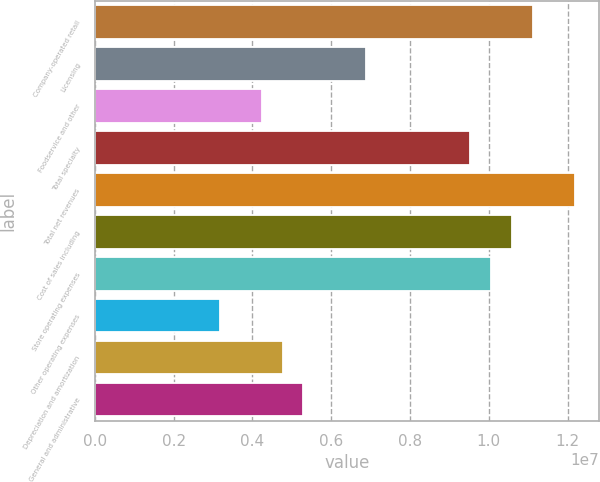Convert chart. <chart><loc_0><loc_0><loc_500><loc_500><bar_chart><fcel>Company-operated retail<fcel>Licensing<fcel>Foodservice and other<fcel>Total specialty<fcel>Total net revenues<fcel>Cost of sales including<fcel>Store operating expenses<fcel>Other operating expenses<fcel>Depreciation and amortization<fcel>General and administrative<nl><fcel>1.11179e+07<fcel>6.88252e+06<fcel>4.2354e+06<fcel>9.52964e+06<fcel>1.21768e+07<fcel>1.05885e+07<fcel>1.00591e+07<fcel>3.17655e+06<fcel>4.76482e+06<fcel>5.29425e+06<nl></chart> 